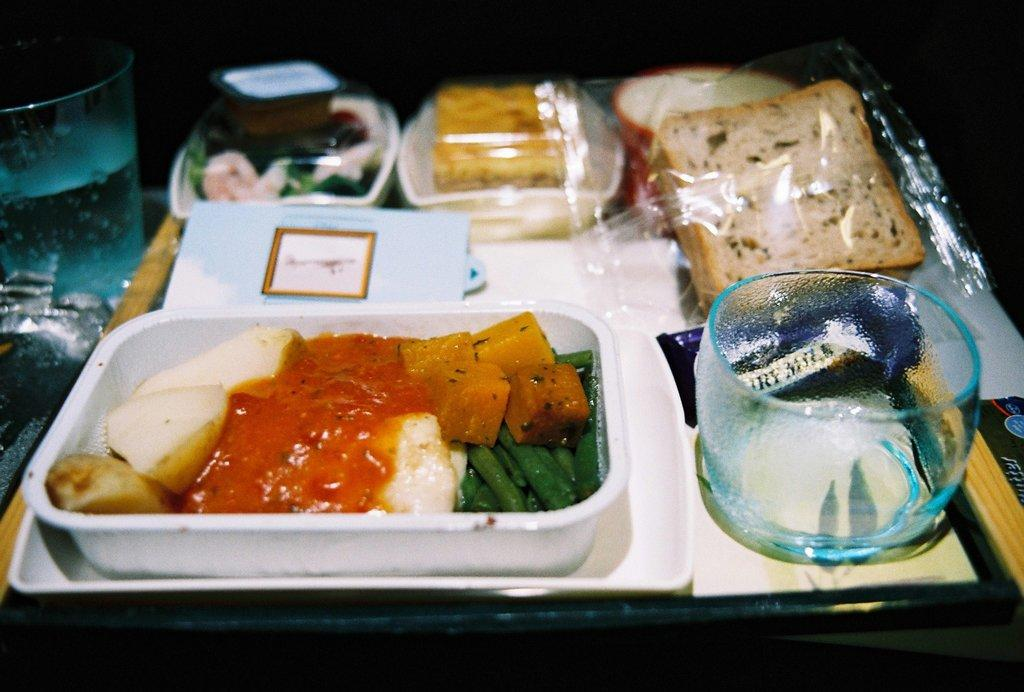What is the main piece of furniture in the image? There is a table in the image. What is placed on the table? There are boxes on the table. What is inside the boxes? The boxes contain food items. What type of beverage is served in the glasses on the table? The glasses contain water. Can you see the parent giving a kiss to the child in the image? There is no parent or child present in the image. What type of bait is used to catch fish in the image? There is no fishing or bait present in the image. 